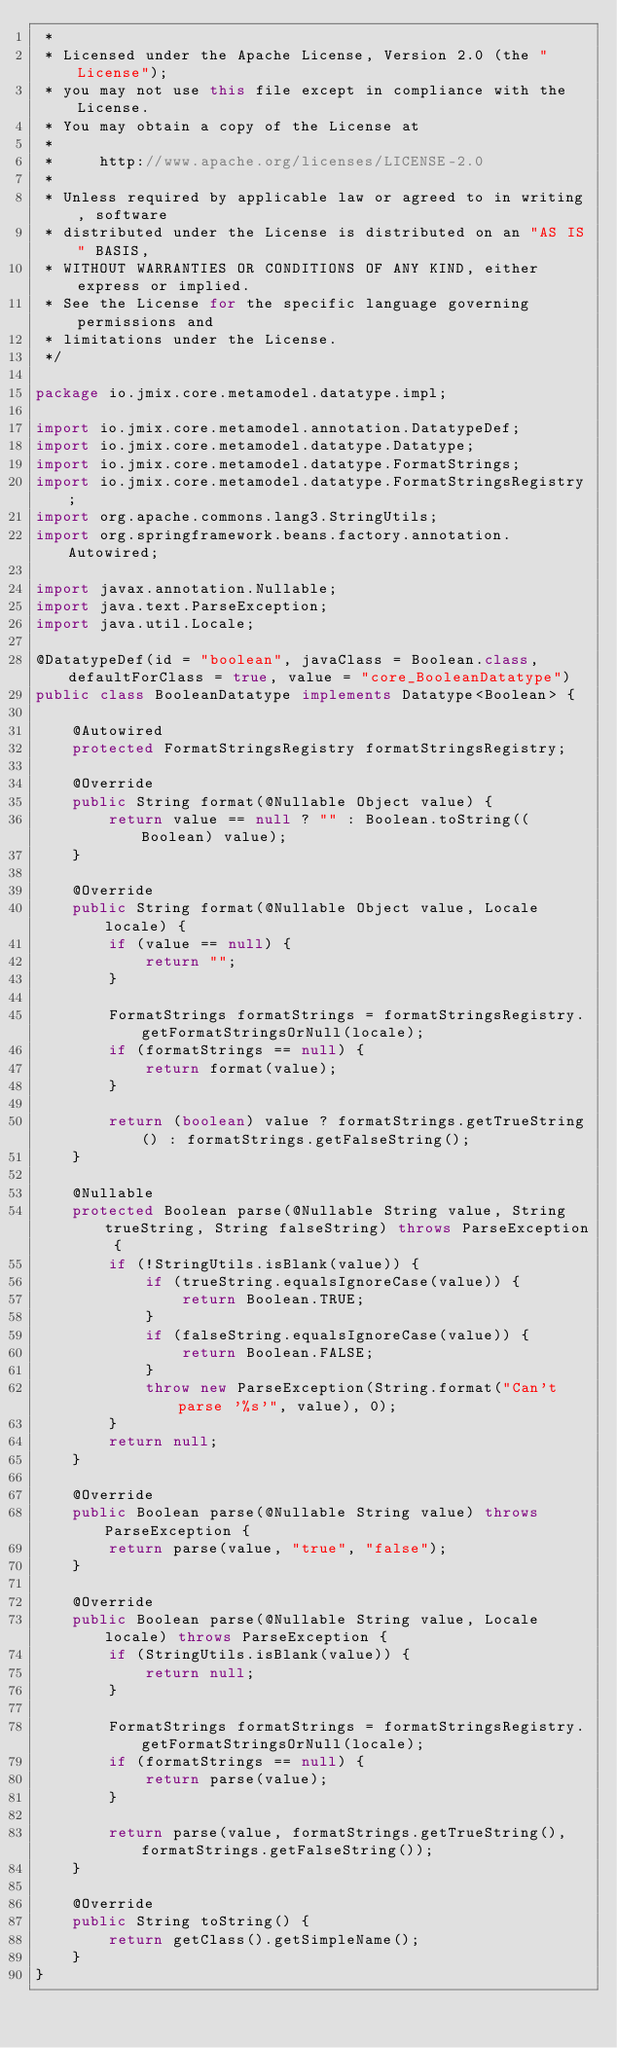<code> <loc_0><loc_0><loc_500><loc_500><_Java_> *
 * Licensed under the Apache License, Version 2.0 (the "License");
 * you may not use this file except in compliance with the License.
 * You may obtain a copy of the License at
 *
 *     http://www.apache.org/licenses/LICENSE-2.0
 *
 * Unless required by applicable law or agreed to in writing, software
 * distributed under the License is distributed on an "AS IS" BASIS,
 * WITHOUT WARRANTIES OR CONDITIONS OF ANY KIND, either express or implied.
 * See the License for the specific language governing permissions and
 * limitations under the License.
 */

package io.jmix.core.metamodel.datatype.impl;

import io.jmix.core.metamodel.annotation.DatatypeDef;
import io.jmix.core.metamodel.datatype.Datatype;
import io.jmix.core.metamodel.datatype.FormatStrings;
import io.jmix.core.metamodel.datatype.FormatStringsRegistry;
import org.apache.commons.lang3.StringUtils;
import org.springframework.beans.factory.annotation.Autowired;

import javax.annotation.Nullable;
import java.text.ParseException;
import java.util.Locale;

@DatatypeDef(id = "boolean", javaClass = Boolean.class, defaultForClass = true, value = "core_BooleanDatatype")
public class BooleanDatatype implements Datatype<Boolean> {

    @Autowired
    protected FormatStringsRegistry formatStringsRegistry;

    @Override
    public String format(@Nullable Object value) {
        return value == null ? "" : Boolean.toString((Boolean) value);
    }

    @Override
    public String format(@Nullable Object value, Locale locale) {
        if (value == null) {
            return "";
        }

        FormatStrings formatStrings = formatStringsRegistry.getFormatStringsOrNull(locale);
        if (formatStrings == null) {
            return format(value);
        }

        return (boolean) value ? formatStrings.getTrueString() : formatStrings.getFalseString();
    }

    @Nullable
    protected Boolean parse(@Nullable String value, String trueString, String falseString) throws ParseException {
        if (!StringUtils.isBlank(value)) {
            if (trueString.equalsIgnoreCase(value)) {
                return Boolean.TRUE;
            }
            if (falseString.equalsIgnoreCase(value)) {
                return Boolean.FALSE;
            }
            throw new ParseException(String.format("Can't parse '%s'", value), 0);
        }
        return null;
    }

    @Override
    public Boolean parse(@Nullable String value) throws ParseException {
        return parse(value, "true", "false");
    }

    @Override
    public Boolean parse(@Nullable String value, Locale locale) throws ParseException {
        if (StringUtils.isBlank(value)) {
            return null;
        }

        FormatStrings formatStrings = formatStringsRegistry.getFormatStringsOrNull(locale);
        if (formatStrings == null) {
            return parse(value);
        }

        return parse(value, formatStrings.getTrueString(), formatStrings.getFalseString());
    }

    @Override
    public String toString() {
        return getClass().getSimpleName();
    }
}</code> 